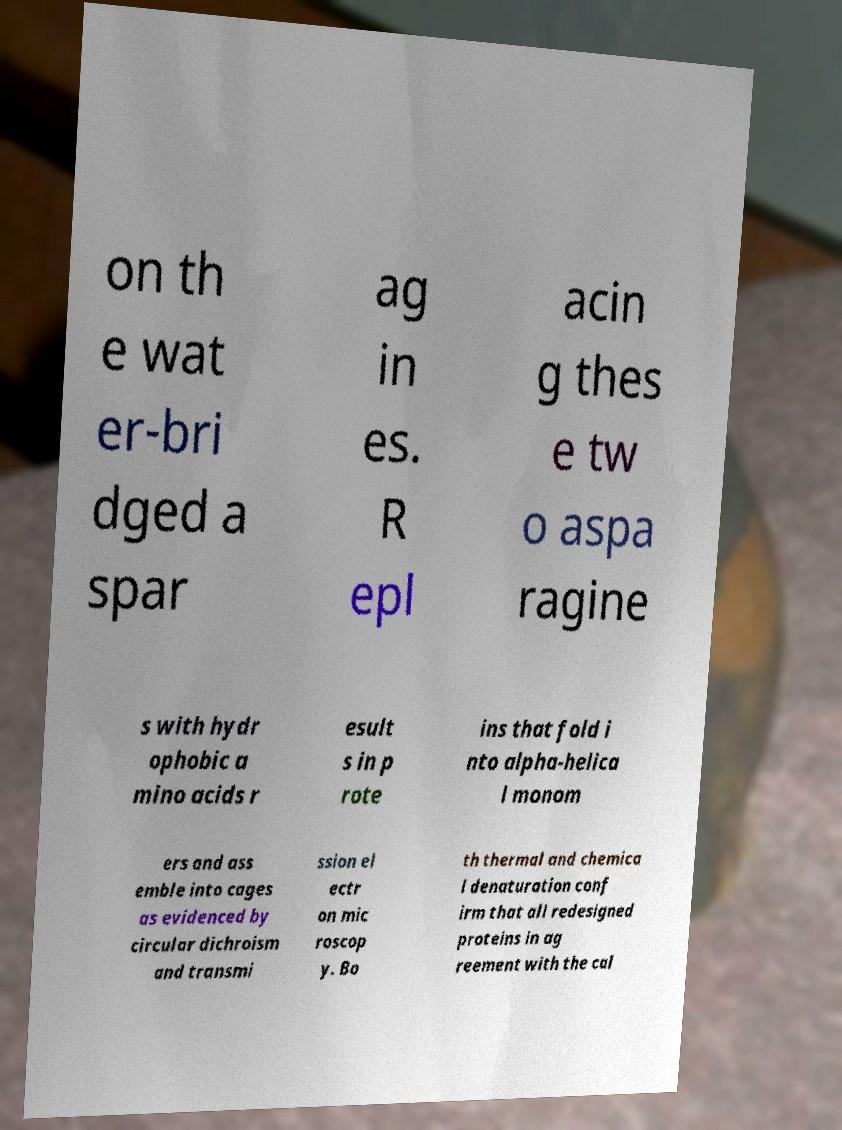Could you extract and type out the text from this image? on th e wat er-bri dged a spar ag in es. R epl acin g thes e tw o aspa ragine s with hydr ophobic a mino acids r esult s in p rote ins that fold i nto alpha-helica l monom ers and ass emble into cages as evidenced by circular dichroism and transmi ssion el ectr on mic roscop y. Bo th thermal and chemica l denaturation conf irm that all redesigned proteins in ag reement with the cal 